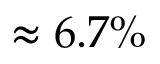<formula> <loc_0><loc_0><loc_500><loc_500>\approx 6 . 7 \%</formula> 